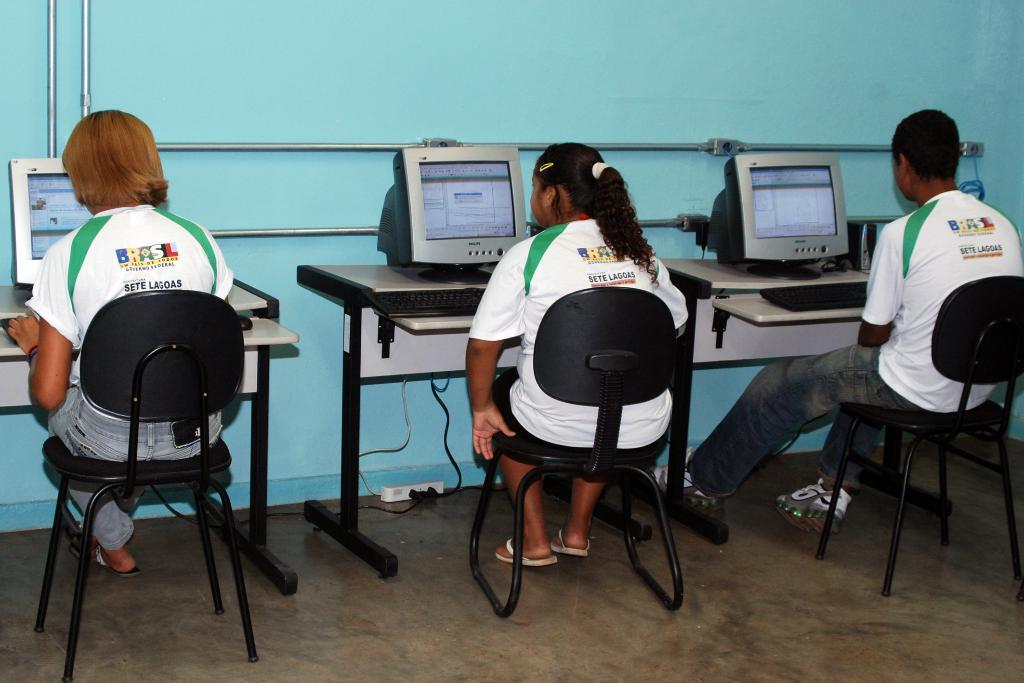How many people are in the image? There are three people in the image. What are the people doing in the image? The people are sitting on a chair. What is in front of the people? The people are in front of a table. What is on the table? There are three monitors on the table. Can you describe the dock and the waves in the image? There is no dock or waves present in the image. 